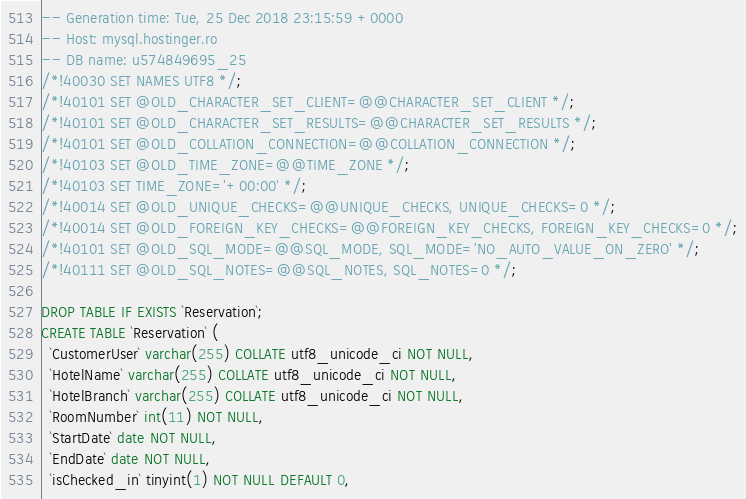<code> <loc_0><loc_0><loc_500><loc_500><_SQL_>-- Generation time: Tue, 25 Dec 2018 23:15:59 +0000
-- Host: mysql.hostinger.ro
-- DB name: u574849695_25
/*!40030 SET NAMES UTF8 */;
/*!40101 SET @OLD_CHARACTER_SET_CLIENT=@@CHARACTER_SET_CLIENT */;
/*!40101 SET @OLD_CHARACTER_SET_RESULTS=@@CHARACTER_SET_RESULTS */;
/*!40101 SET @OLD_COLLATION_CONNECTION=@@COLLATION_CONNECTION */;
/*!40103 SET @OLD_TIME_ZONE=@@TIME_ZONE */;
/*!40103 SET TIME_ZONE='+00:00' */;
/*!40014 SET @OLD_UNIQUE_CHECKS=@@UNIQUE_CHECKS, UNIQUE_CHECKS=0 */;
/*!40014 SET @OLD_FOREIGN_KEY_CHECKS=@@FOREIGN_KEY_CHECKS, FOREIGN_KEY_CHECKS=0 */;
/*!40101 SET @OLD_SQL_MODE=@@SQL_MODE, SQL_MODE='NO_AUTO_VALUE_ON_ZERO' */;
/*!40111 SET @OLD_SQL_NOTES=@@SQL_NOTES, SQL_NOTES=0 */;

DROP TABLE IF EXISTS `Reservation`;
CREATE TABLE `Reservation` (
  `CustomerUser` varchar(255) COLLATE utf8_unicode_ci NOT NULL,
  `HotelName` varchar(255) COLLATE utf8_unicode_ci NOT NULL,
  `HotelBranch` varchar(255) COLLATE utf8_unicode_ci NOT NULL,
  `RoomNumber` int(11) NOT NULL,
  `StartDate` date NOT NULL,
  `EndDate` date NOT NULL,
  `isChecked_in` tinyint(1) NOT NULL DEFAULT 0,</code> 